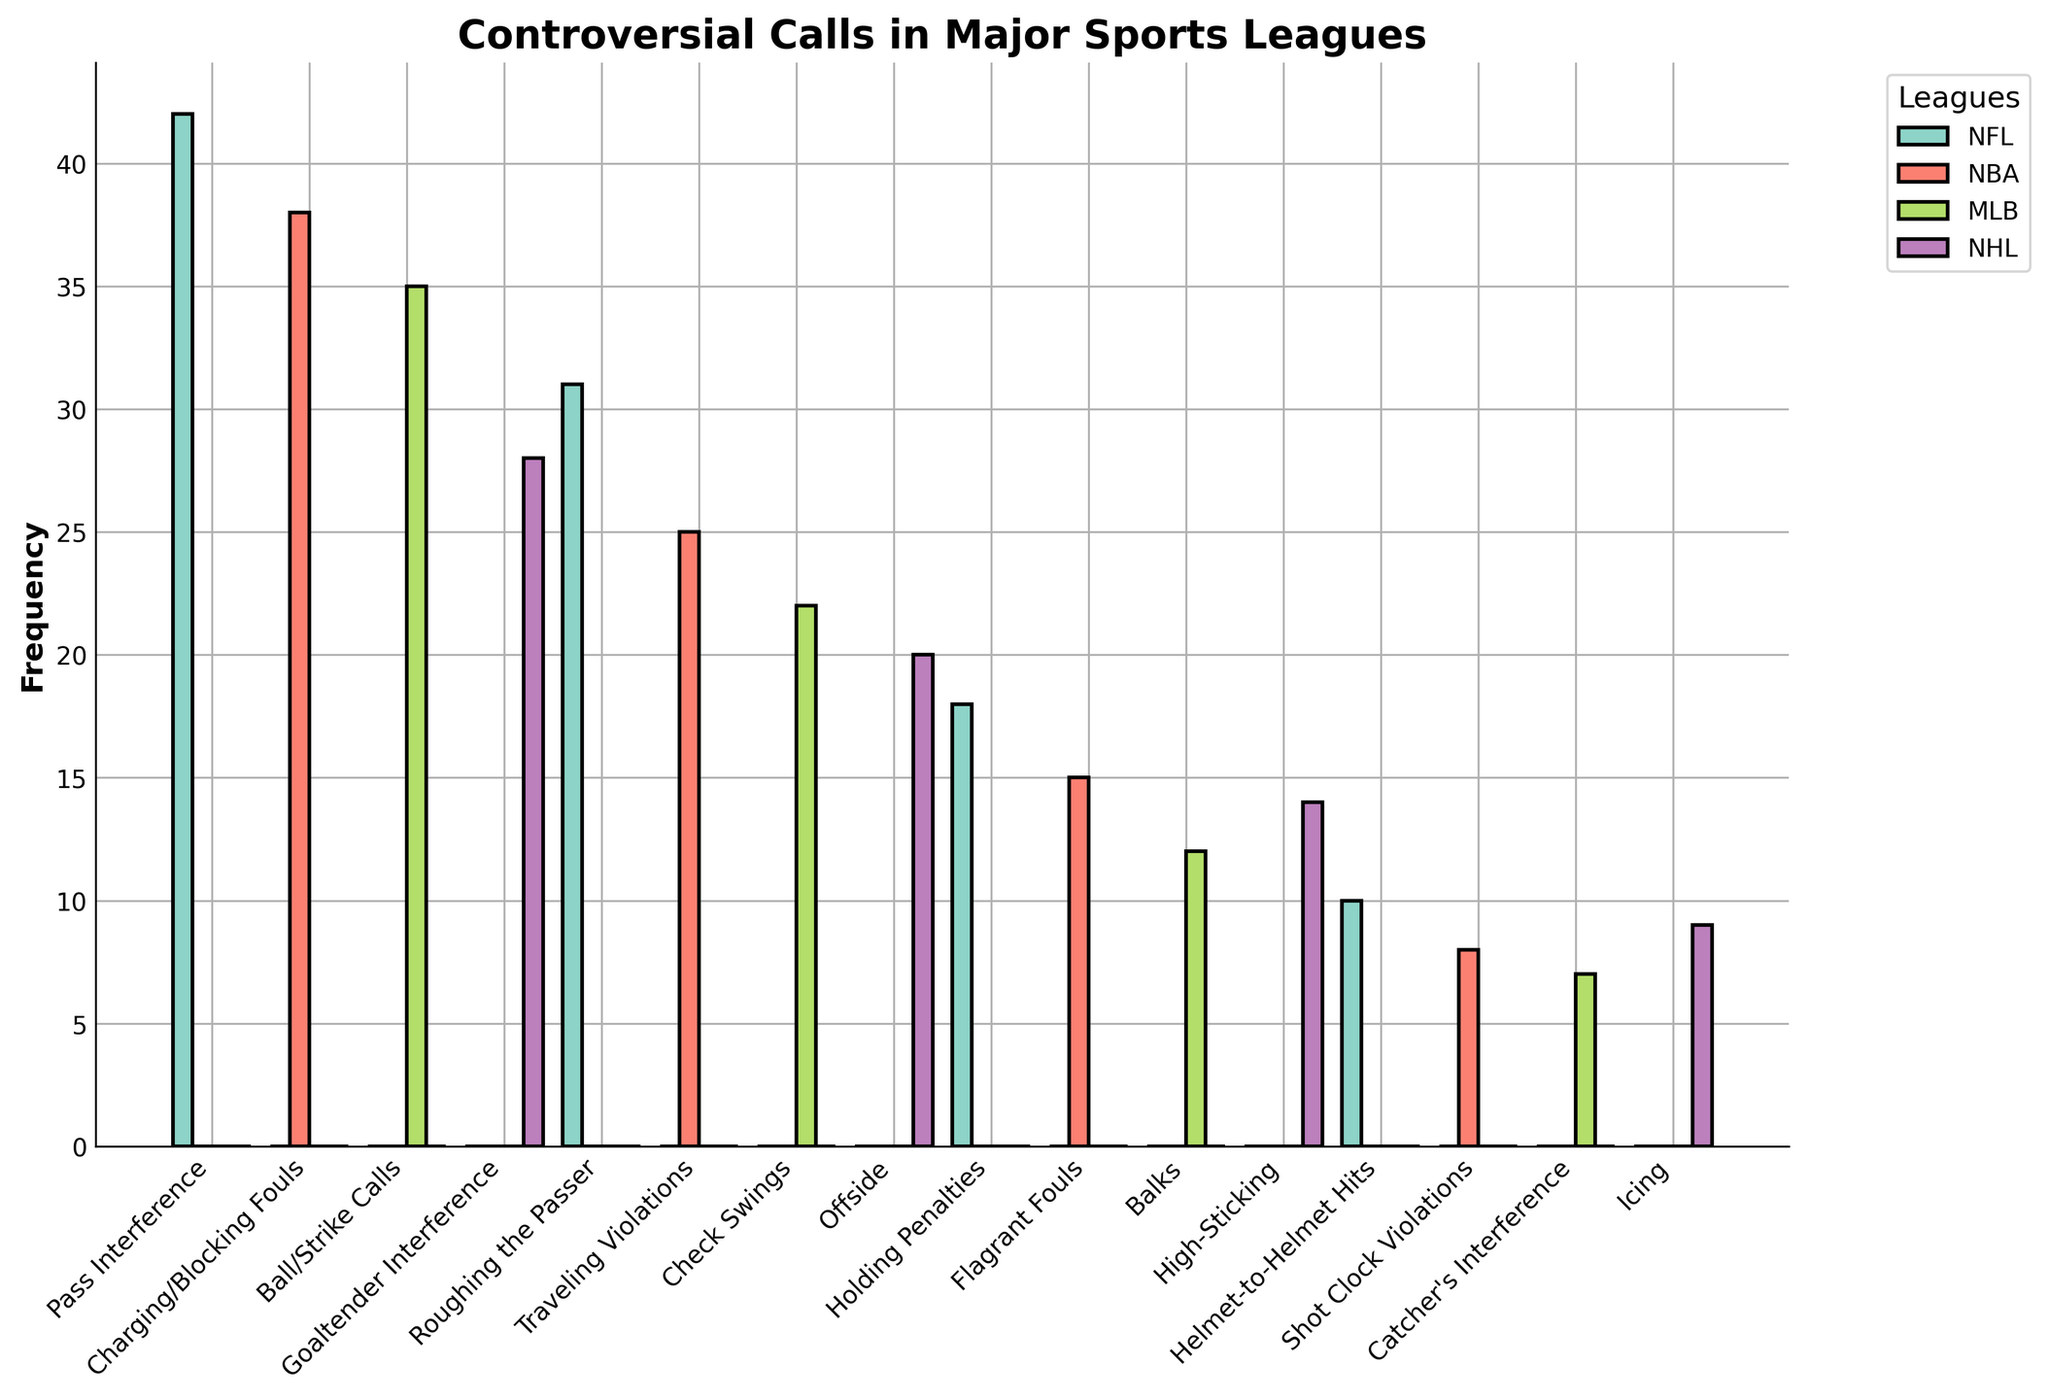What's the most frequent type of controversial call in the NFL? By looking at the heights of the bars corresponding to NFL in the figure, the highest bar is for Pass Interference with a frequency of 42.
Answer: Pass Interference Which league has the most diverse set of controversial calls in the figure? By counting the different types of bars for each league, the NFL has the highest number of different controversial call types (6 types).
Answer: NFL Compare the frequency of Charging/Blocking Fouls in the NBA to Roughing the Passer in the NFL. Which is higher and by how much? The bar for Charging/Blocking Fouls in the NBA has a frequency of 38, while the bar for Roughing the Passer in the NFL has a frequency of 31. The difference is 38 - 31 = 7.
Answer: Charging/Blocking Fouls by 7 What is the combined frequency of all controversial calls in the MLB? Adding the heights of the bars corresponding to MLB: Ball/Strike Calls (35) + Check Swings (22) + Balks (12) + Catcher's Interference (7) = 35 + 22 + 12 + 7 = 76.
Answer: 76 What is the least frequent controversial call in the NHL based on the figure? The shortest bar for NHL is Icing, with a frequency of 9.
Answer: Icing Which has a higher frequency: Traveling Violations in the NBA or Holding Penalties in the NFL? By comparing the heights of the respective bars, Traveling Violations in the NBA has a frequency of 25, while Holding Penalties in the NFL has a frequency of 18.
Answer: Traveling Violations What is the difference in the frequency of Goaltender Interference in the NHL and Helmet-to-Helmet Hits in the NFL? Goaltender Interference in the NHL has a frequency of 28, and Helmet-to-Helmet Hits in the NFL has a frequency of 10. The difference is 28 - 10 = 18.
Answer: 18 How does the frequency of Offside calls in the NHL compare to High-Sticking? By examining the heights of the respective bars for NHL, Offside has a frequency of 20 while High-Sticking has a frequency of 14.
Answer: Offside What's the median frequency of the controversial call types in the NBA? The controversial call types in the NBA have frequencies of 38, 25, 15, and 8. Arranging them in order: 8, 15, 25, 38, the median is (15 + 25) / 2 = 20.
Answer: 20 